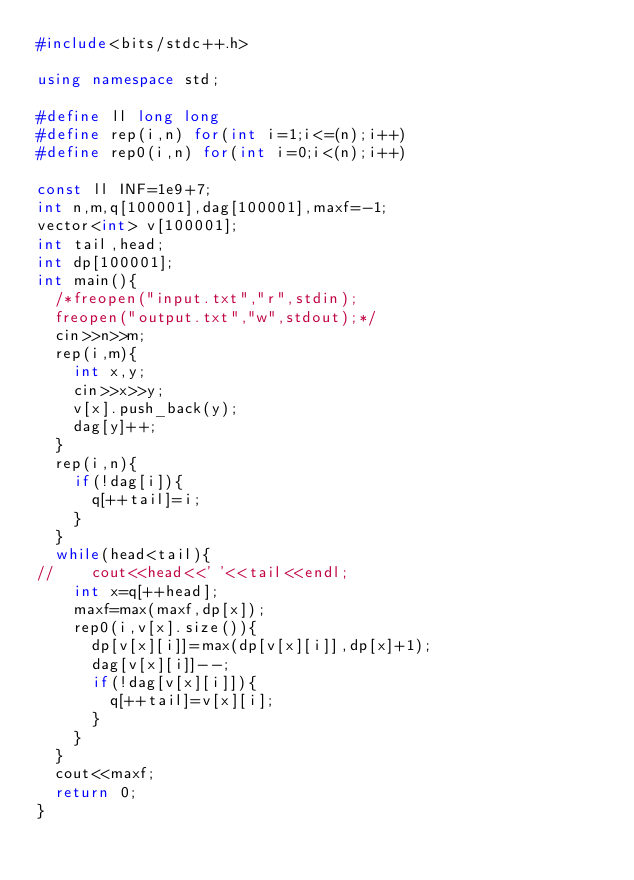Convert code to text. <code><loc_0><loc_0><loc_500><loc_500><_C++_>#include<bits/stdc++.h>

using namespace std;

#define ll long long
#define rep(i,n) for(int i=1;i<=(n);i++)
#define rep0(i,n) for(int i=0;i<(n);i++)

const ll INF=1e9+7;
int n,m,q[100001],dag[100001],maxf=-1;
vector<int> v[100001];
int tail,head;
int dp[100001];
int main(){
	/*freopen("input.txt","r",stdin);
	freopen("output.txt","w",stdout);*/
	cin>>n>>m;
	rep(i,m){
		int x,y;
		cin>>x>>y;
		v[x].push_back(y);
		dag[y]++;
	}
	rep(i,n){
		if(!dag[i]){
			q[++tail]=i;
		}
	}
	while(head<tail){
//		cout<<head<<' '<<tail<<endl;
		int x=q[++head];
		maxf=max(maxf,dp[x]);
		rep0(i,v[x].size()){
			dp[v[x][i]]=max(dp[v[x][i]],dp[x]+1);
			dag[v[x][i]]--;
			if(!dag[v[x][i]]){
				q[++tail]=v[x][i];
			}
		}
	}
	cout<<maxf;
	return 0;
}</code> 